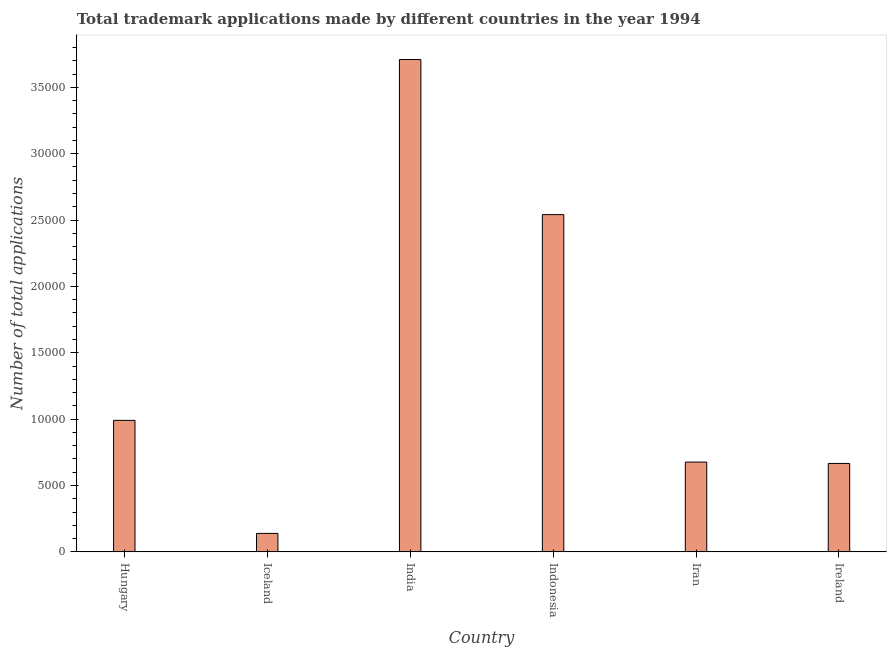Does the graph contain any zero values?
Make the answer very short. No. What is the title of the graph?
Give a very brief answer. Total trademark applications made by different countries in the year 1994. What is the label or title of the X-axis?
Keep it short and to the point. Country. What is the label or title of the Y-axis?
Provide a succinct answer. Number of total applications. What is the number of trademark applications in Indonesia?
Offer a terse response. 2.54e+04. Across all countries, what is the maximum number of trademark applications?
Give a very brief answer. 3.71e+04. Across all countries, what is the minimum number of trademark applications?
Your response must be concise. 1392. In which country was the number of trademark applications minimum?
Your response must be concise. Iceland. What is the sum of the number of trademark applications?
Provide a succinct answer. 8.72e+04. What is the difference between the number of trademark applications in Iceland and Iran?
Your answer should be compact. -5373. What is the average number of trademark applications per country?
Offer a very short reply. 1.45e+04. What is the median number of trademark applications?
Give a very brief answer. 8336.5. In how many countries, is the number of trademark applications greater than 8000 ?
Provide a short and direct response. 3. What is the ratio of the number of trademark applications in India to that in Indonesia?
Your answer should be very brief. 1.46. Is the difference between the number of trademark applications in Hungary and India greater than the difference between any two countries?
Your answer should be compact. No. What is the difference between the highest and the second highest number of trademark applications?
Ensure brevity in your answer.  1.17e+04. What is the difference between the highest and the lowest number of trademark applications?
Your answer should be very brief. 3.57e+04. How many bars are there?
Your answer should be compact. 6. What is the difference between two consecutive major ticks on the Y-axis?
Offer a very short reply. 5000. Are the values on the major ticks of Y-axis written in scientific E-notation?
Keep it short and to the point. No. What is the Number of total applications in Hungary?
Provide a short and direct response. 9908. What is the Number of total applications in Iceland?
Provide a succinct answer. 1392. What is the Number of total applications of India?
Provide a short and direct response. 3.71e+04. What is the Number of total applications in Indonesia?
Ensure brevity in your answer.  2.54e+04. What is the Number of total applications of Iran?
Provide a short and direct response. 6765. What is the Number of total applications in Ireland?
Provide a short and direct response. 6662. What is the difference between the Number of total applications in Hungary and Iceland?
Offer a very short reply. 8516. What is the difference between the Number of total applications in Hungary and India?
Ensure brevity in your answer.  -2.72e+04. What is the difference between the Number of total applications in Hungary and Indonesia?
Make the answer very short. -1.55e+04. What is the difference between the Number of total applications in Hungary and Iran?
Your answer should be very brief. 3143. What is the difference between the Number of total applications in Hungary and Ireland?
Keep it short and to the point. 3246. What is the difference between the Number of total applications in Iceland and India?
Ensure brevity in your answer.  -3.57e+04. What is the difference between the Number of total applications in Iceland and Indonesia?
Offer a very short reply. -2.40e+04. What is the difference between the Number of total applications in Iceland and Iran?
Offer a very short reply. -5373. What is the difference between the Number of total applications in Iceland and Ireland?
Your answer should be very brief. -5270. What is the difference between the Number of total applications in India and Indonesia?
Offer a terse response. 1.17e+04. What is the difference between the Number of total applications in India and Iran?
Your response must be concise. 3.03e+04. What is the difference between the Number of total applications in India and Ireland?
Your answer should be very brief. 3.04e+04. What is the difference between the Number of total applications in Indonesia and Iran?
Provide a succinct answer. 1.86e+04. What is the difference between the Number of total applications in Indonesia and Ireland?
Give a very brief answer. 1.87e+04. What is the difference between the Number of total applications in Iran and Ireland?
Provide a succinct answer. 103. What is the ratio of the Number of total applications in Hungary to that in Iceland?
Your response must be concise. 7.12. What is the ratio of the Number of total applications in Hungary to that in India?
Keep it short and to the point. 0.27. What is the ratio of the Number of total applications in Hungary to that in Indonesia?
Your answer should be compact. 0.39. What is the ratio of the Number of total applications in Hungary to that in Iran?
Provide a succinct answer. 1.47. What is the ratio of the Number of total applications in Hungary to that in Ireland?
Provide a succinct answer. 1.49. What is the ratio of the Number of total applications in Iceland to that in India?
Provide a short and direct response. 0.04. What is the ratio of the Number of total applications in Iceland to that in Indonesia?
Provide a short and direct response. 0.06. What is the ratio of the Number of total applications in Iceland to that in Iran?
Provide a succinct answer. 0.21. What is the ratio of the Number of total applications in Iceland to that in Ireland?
Ensure brevity in your answer.  0.21. What is the ratio of the Number of total applications in India to that in Indonesia?
Provide a succinct answer. 1.46. What is the ratio of the Number of total applications in India to that in Iran?
Offer a terse response. 5.48. What is the ratio of the Number of total applications in India to that in Ireland?
Provide a succinct answer. 5.57. What is the ratio of the Number of total applications in Indonesia to that in Iran?
Keep it short and to the point. 3.76. What is the ratio of the Number of total applications in Indonesia to that in Ireland?
Offer a terse response. 3.81. 